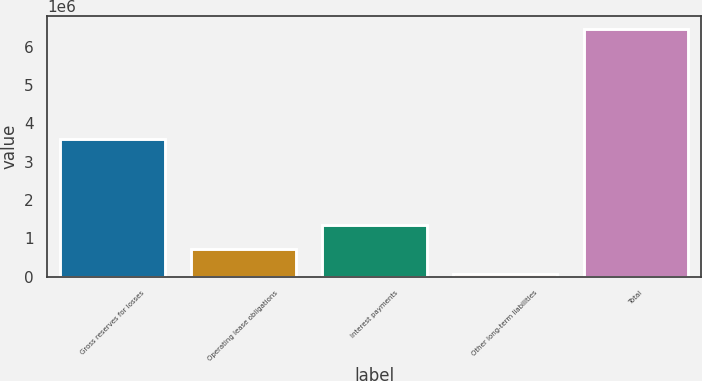Convert chart. <chart><loc_0><loc_0><loc_500><loc_500><bar_chart><fcel>Gross reserves for losses<fcel>Operating lease obligations<fcel>Interest payments<fcel>Other long-term liabilities<fcel>Total<nl><fcel>3.59198e+06<fcel>708059<fcel>1.34809e+06<fcel>68031<fcel>6.46831e+06<nl></chart> 